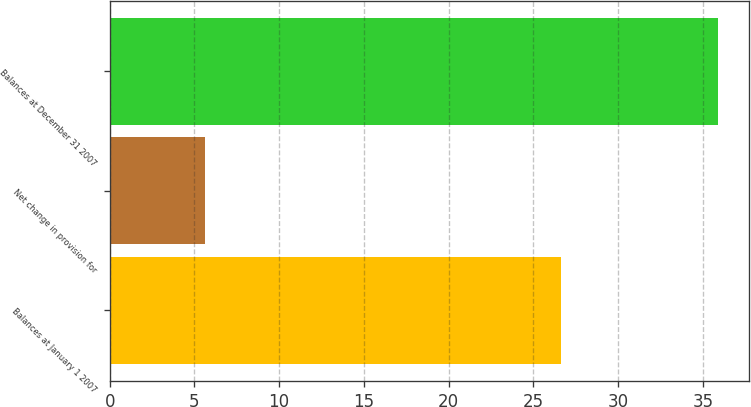<chart> <loc_0><loc_0><loc_500><loc_500><bar_chart><fcel>Balances at January 1 2007<fcel>Net change in provision for<fcel>Balances at December 31 2007<nl><fcel>26.6<fcel>5.6<fcel>35.9<nl></chart> 